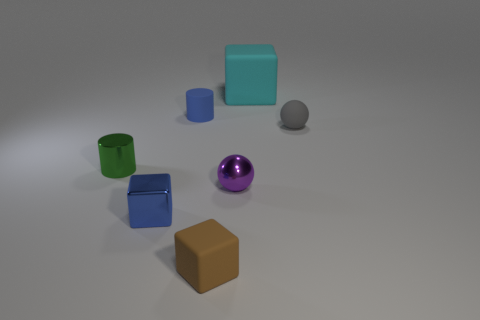Add 1 brown rubber blocks. How many objects exist? 8 Subtract all blue blocks. How many blocks are left? 2 Subtract 1 cylinders. How many cylinders are left? 1 Subtract all brown cylinders. Subtract all purple blocks. How many cylinders are left? 2 Subtract all purple cylinders. How many brown cubes are left? 1 Subtract all large purple rubber spheres. Subtract all large matte blocks. How many objects are left? 6 Add 4 purple shiny things. How many purple shiny things are left? 5 Add 6 small rubber cylinders. How many small rubber cylinders exist? 7 Subtract all gray balls. How many balls are left? 1 Subtract 0 yellow cylinders. How many objects are left? 7 